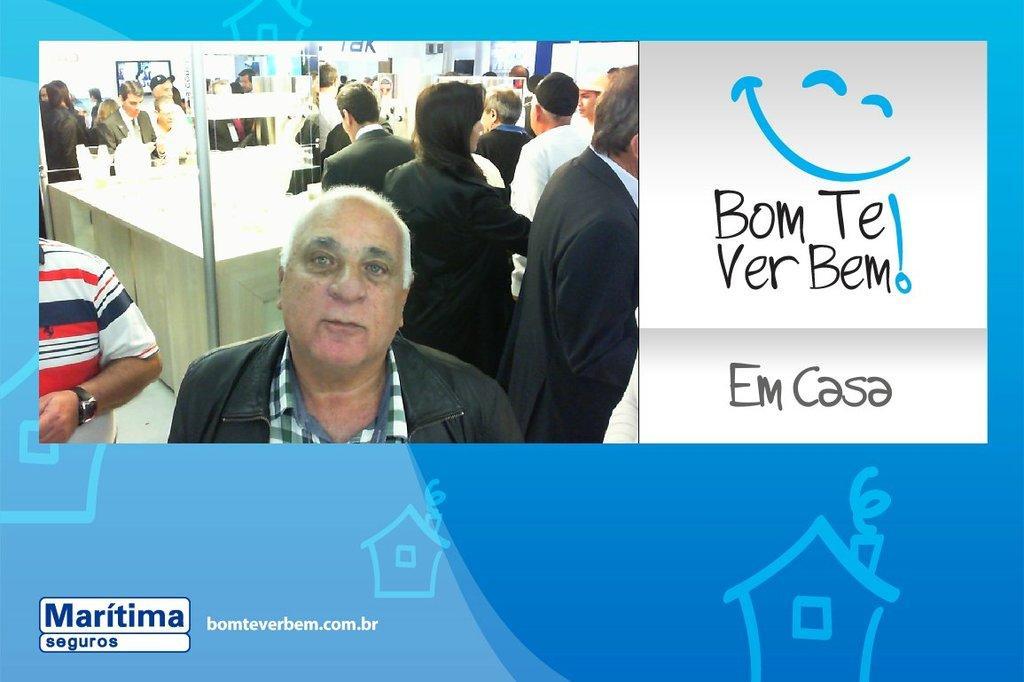Please provide a concise description of this image. In this image I can see a picture in which I can see few persons wearing black and white colored dresses are standing and the white colored wall. I can see something is written with black color on the white colored surface and blue colored background. 